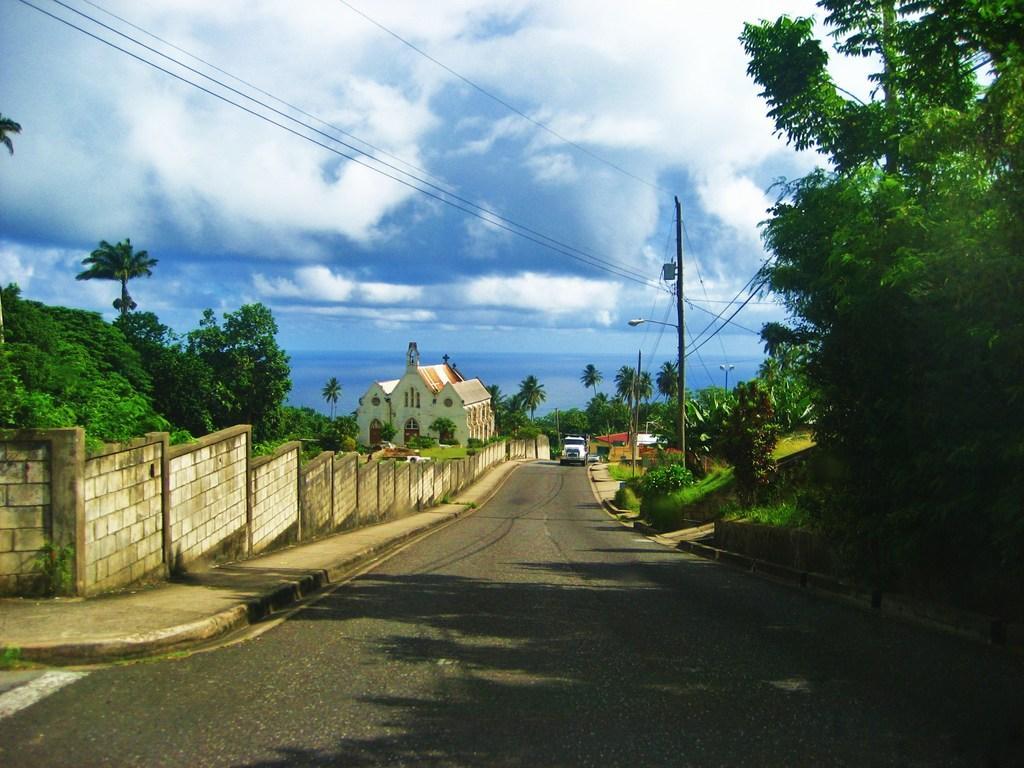Please provide a concise description of this image. In this image there is a vehicle on a road, on the left side there is a wall, trees and a house, on the right side there are trees, poles, wires and the sky. 